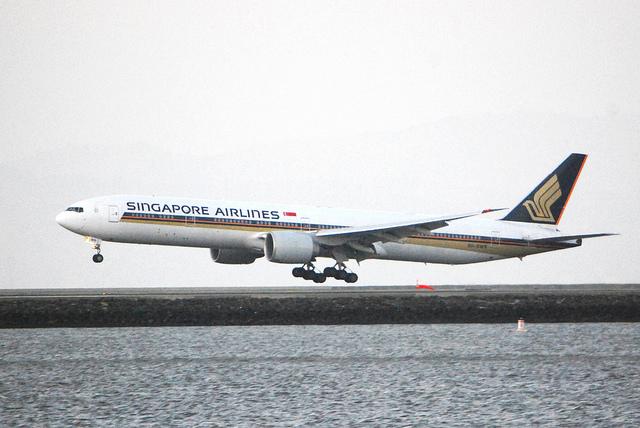Is this an overcast day?
Answer briefly. No. What airlines is this?
Short answer required. Singapore. What kind of animal is in the logo on the tail?
Give a very brief answer. Bird. What is the weather like?
Short answer required. Cloudy. Is the plane taking off?
Keep it brief. Yes. Is the airplane moving?
Concise answer only. Yes. 